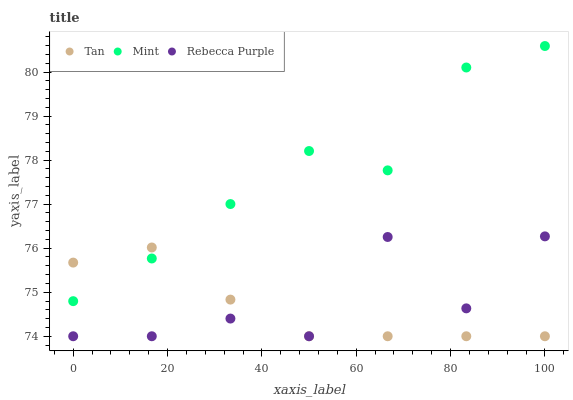Does Tan have the minimum area under the curve?
Answer yes or no. Yes. Does Mint have the maximum area under the curve?
Answer yes or no. Yes. Does Rebecca Purple have the minimum area under the curve?
Answer yes or no. No. Does Rebecca Purple have the maximum area under the curve?
Answer yes or no. No. Is Tan the smoothest?
Answer yes or no. Yes. Is Rebecca Purple the roughest?
Answer yes or no. Yes. Is Mint the smoothest?
Answer yes or no. No. Is Mint the roughest?
Answer yes or no. No. Does Tan have the lowest value?
Answer yes or no. Yes. Does Mint have the lowest value?
Answer yes or no. No. Does Mint have the highest value?
Answer yes or no. Yes. Does Rebecca Purple have the highest value?
Answer yes or no. No. Is Rebecca Purple less than Mint?
Answer yes or no. Yes. Is Mint greater than Rebecca Purple?
Answer yes or no. Yes. Does Tan intersect Mint?
Answer yes or no. Yes. Is Tan less than Mint?
Answer yes or no. No. Is Tan greater than Mint?
Answer yes or no. No. Does Rebecca Purple intersect Mint?
Answer yes or no. No. 